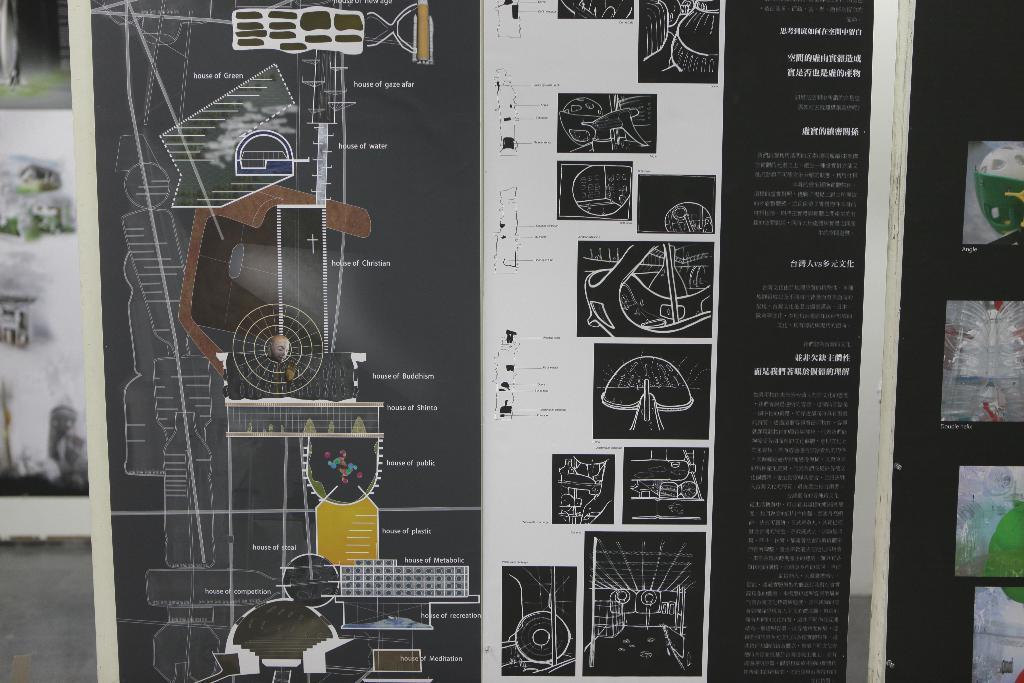Could you give a brief overview of what you see in this image? In this image we can see a banner with text and images. 